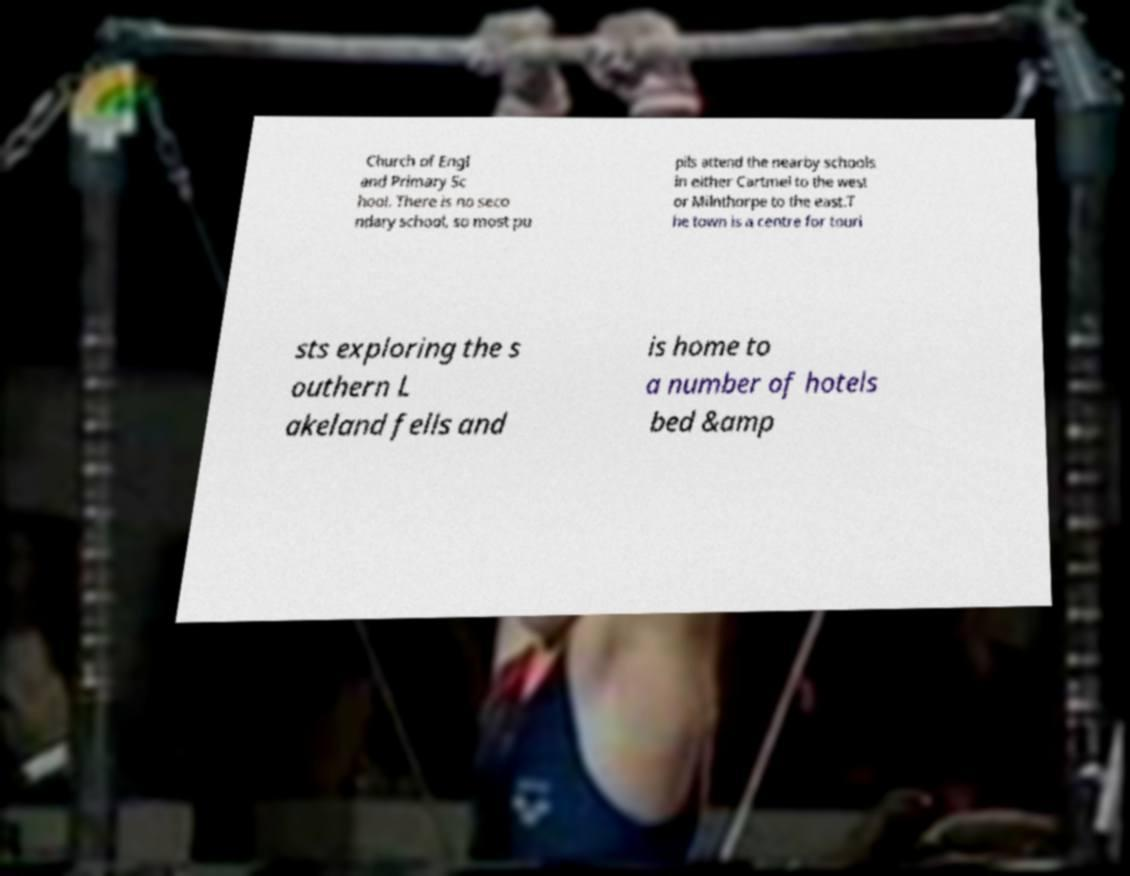Could you assist in decoding the text presented in this image and type it out clearly? Church of Engl and Primary Sc hool. There is no seco ndary school, so most pu pils attend the nearby schools in either Cartmel to the west or Milnthorpe to the east.T he town is a centre for touri sts exploring the s outhern L akeland fells and is home to a number of hotels bed &amp 